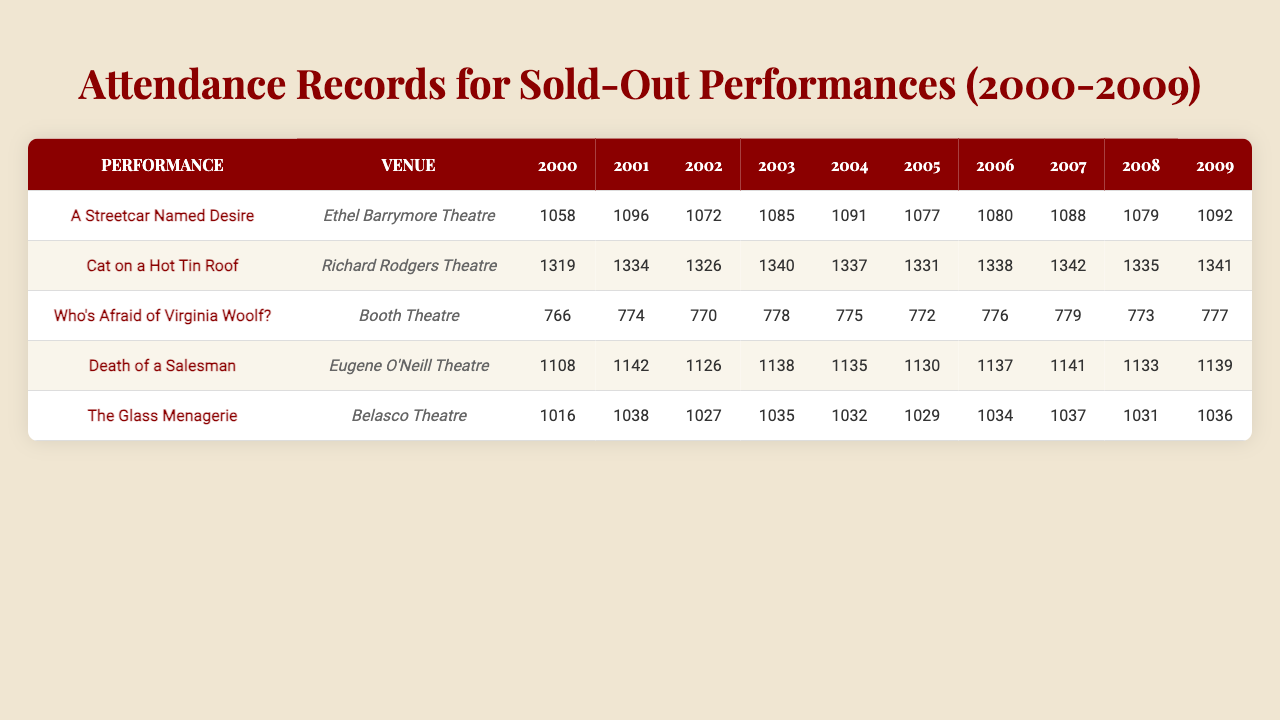What was the highest attendance for "A Streetcar Named Desire" during the decade? The attendance values for "A Streetcar Named Desire" from 2000 to 2009 are 1058, 1096, 1072, 1085, 1091, 1077, 1080, 1088, 1079, and 1092. The highest value among these is 1096 in the year 2001.
Answer: 1096 What year had the lowest attendance for "Who's Afraid of Virginia Woolf?" The attendance values for "Who's Afraid of Virginia Woolf?" are 766, 774, 770, 778, 775, 772, 776, 779, 773, and 777. The lowest value in these figures is 766 in the year 2000.
Answer: 2000 Which performance had the highest average attendance over the decade? To find the average attendance for each performance, sum the attendance values and divide by the number of years. The averages are: for “A Streetcar Named Desire”: 1082.7, “Cat on a Hot Tin Roof”: 1335.6, “Who's Afraid of Virginia Woolf?”: 774.6, “Death of a Salesman”: 1135.8, and “The Glass Menagerie”: 1032.9. The highest average attendance is for “Cat on a Hot Tin Roof” at 1335.6.
Answer: Cat on a Hot Tin Roof True or False: The total attendance for "The Glass Menagerie" in 2003 was greater than 1025. The attendance for "The Glass Menagerie" in 2003 is 1035, which is indeed greater than 1025. Thus, the statement is True.
Answer: True What was the overall attendance trend for "Death of a Salesman" over the decade? Analyzing the attendance from 2000 to 2009: 1108, 1142, 1126, 1138, 1135, 1130, 1137, 1141, 1133, 1139 shows a slight upward trend with fluctuations. The general tendency appears to be stable or slightly increasing.
Answer: Slight upward trend In which performance did the actress have a consistently increasing attendance from year to year? To check for consistently increasing attendance, look at the attendance numbers: for "Cat on a Hot Tin Roof": all values are increasing from 1319 to 1341 yearly without any decline. The performance consistently shows an increase over the years.
Answer: Cat on a Hot Tin Roof What was the total attendance for all performances in 2005? Summing the attendance for all performances in 2005, we have: 1077 (A Streetcar Named Desire) + 1331 (Cat on a Hot Tin Roof) + 772 (Who's Afraid of Virginia Woolf) + 1130 (Death of a Salesman) + 1029 (The Glass Menagerie) = 6339.
Answer: 6339 How does the attendance for "Death of a Salesman" in 2002 compare to "A Streetcar Named Desire" in the same year? The attendance for "Death of a Salesman" in 2002 is 1126 and for "A Streetcar Named Desire" is 1072. Since 1126 is greater than 1072, "Death of a Salesman" had higher attendance in 2002.
Answer: Higher for Death of a Salesman Which venue had the lowest total attendance summed over all years? First, we calculate the total attendance for each venue: Ethel Barrymore Theatre: 1058 + 1096 + 1072 + 1085 + 1091 + 1077 + 1080 + 1088 + 1079 + 1092 = 10883; Richard Rodgers Theatre: 1319 + 1334 + 1326 + 1340 + 1337 + 1331 + 1338 + 1342 + 1335 + 1341 = 13302; Booth Theatre: 766 + 774 + 770 + 778 + 775 + 772 + 776 + 779 + 773 + 777 = 7710; Eugene O'Neill Theatre: 1108 + 1142 + 1126 + 1138 + 1135 + 1130 + 1137 + 1141 + 1133 + 1139 = 11381; Belasco Theatre: 1016 + 1038 + 1027 + 1035 + 1032 + 1029 + 1034 + 1037 + 1031 + 1036 = 10396. The lowest total attendance is for Booth Theatre at 7710.
Answer: Booth Theatre 